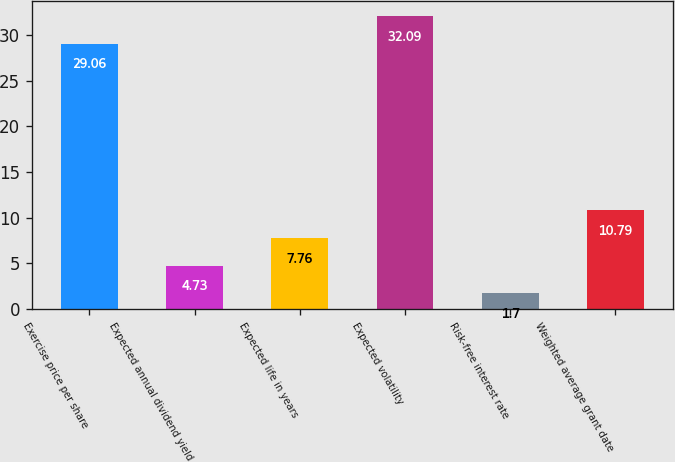Convert chart to OTSL. <chart><loc_0><loc_0><loc_500><loc_500><bar_chart><fcel>Exercise price per share<fcel>Expected annual dividend yield<fcel>Expected life in years<fcel>Expected volatility<fcel>Risk-free interest rate<fcel>Weighted average grant date<nl><fcel>29.06<fcel>4.73<fcel>7.76<fcel>32.09<fcel>1.7<fcel>10.79<nl></chart> 